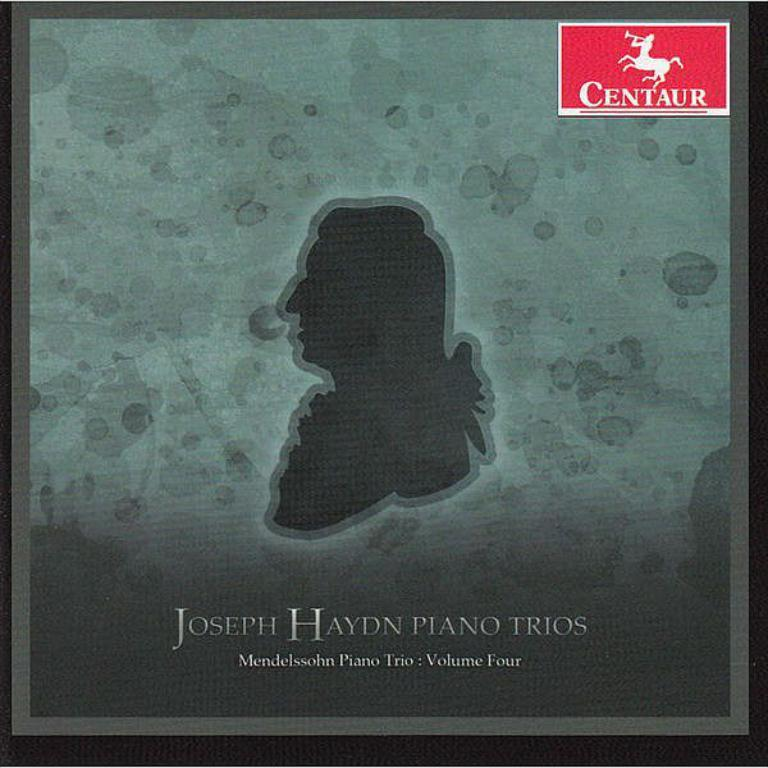What is the main object in the image that resembles a poster? There is an object in the image that resembles a poster. What can be found on the poster? The poster contains text and pictures. How many dinosaurs are jumping on the crib in the image? There are no dinosaurs or cribs present in the image. 